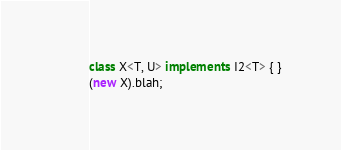Convert code to text. <code><loc_0><loc_0><loc_500><loc_500><_TypeScript_>class X<T, U> implements I2<T> { }
(new X).blah;</code> 